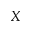<formula> <loc_0><loc_0><loc_500><loc_500>X</formula> 